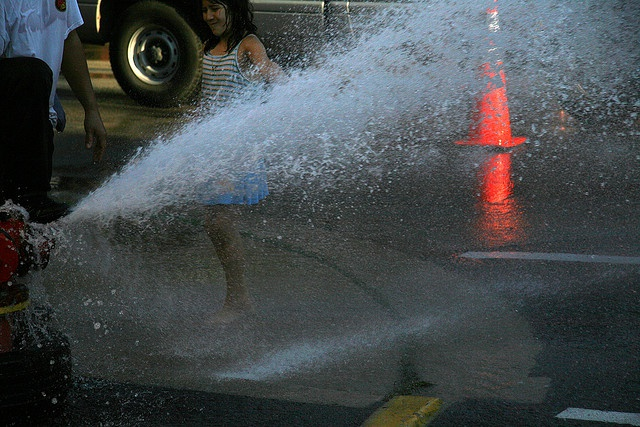Describe the objects in this image and their specific colors. I can see truck in teal, black, gray, darkgray, and darkgreen tones, car in teal, black, gray, and darkgreen tones, people in teal, black, gray, and darkgray tones, fire hydrant in teal, black, gray, maroon, and purple tones, and people in teal, black, gray, and blue tones in this image. 